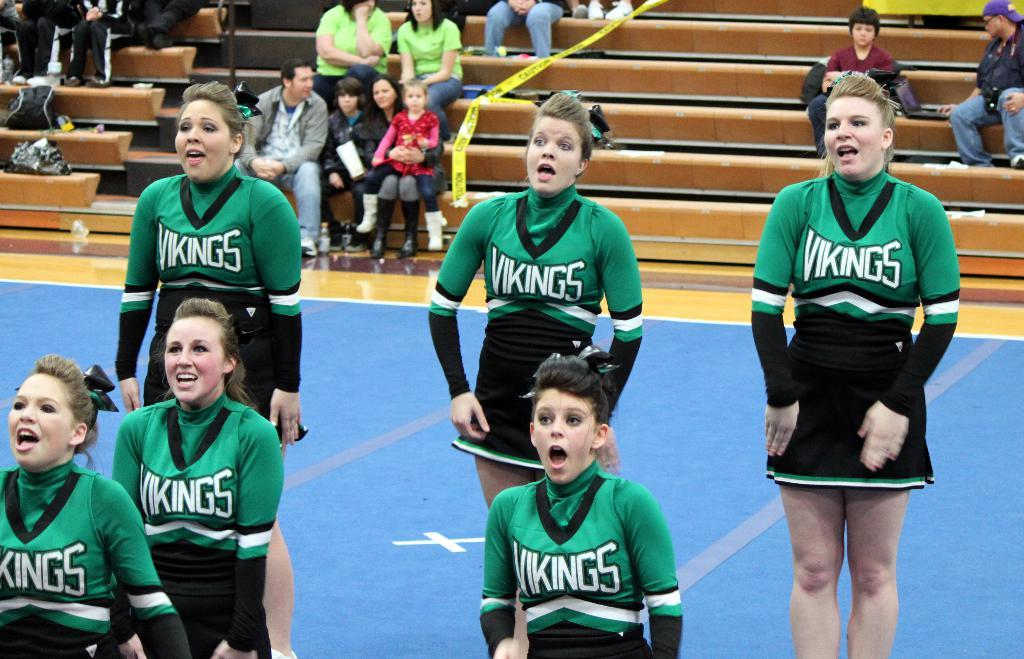<image>
Offer a succinct explanation of the picture presented. a few cheerleaders cheering with Vikings outfits on 